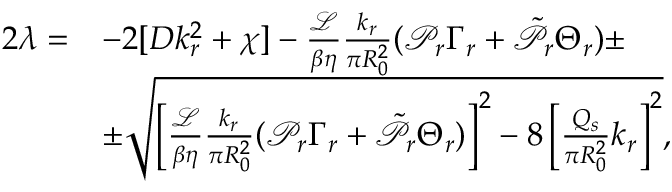<formula> <loc_0><loc_0><loc_500><loc_500>\begin{array} { r l } { 2 \lambda = } & { - 2 [ D k _ { r } ^ { 2 } + \chi ] - \frac { \mathcal { L } } { \beta \eta } \frac { k _ { r } } { \pi R _ { 0 } ^ { 2 } } ( \mathcal { P } _ { r } \Gamma _ { r } + \tilde { \mathcal { P } } _ { r } \Theta _ { r } ) \pm } \\ & { \pm \sqrt { \left [ \frac { \mathcal { L } } { \beta \eta } \frac { k _ { r } } { \pi R _ { 0 } ^ { 2 } } ( \mathcal { P } _ { r } \Gamma _ { r } + \tilde { \mathcal { P } } _ { r } \Theta _ { r } ) \right ] ^ { 2 } - 8 \left [ \frac { Q _ { s } } { \pi R _ { 0 } ^ { 2 } } k _ { r } \right ] ^ { 2 } } , } \end{array}</formula> 